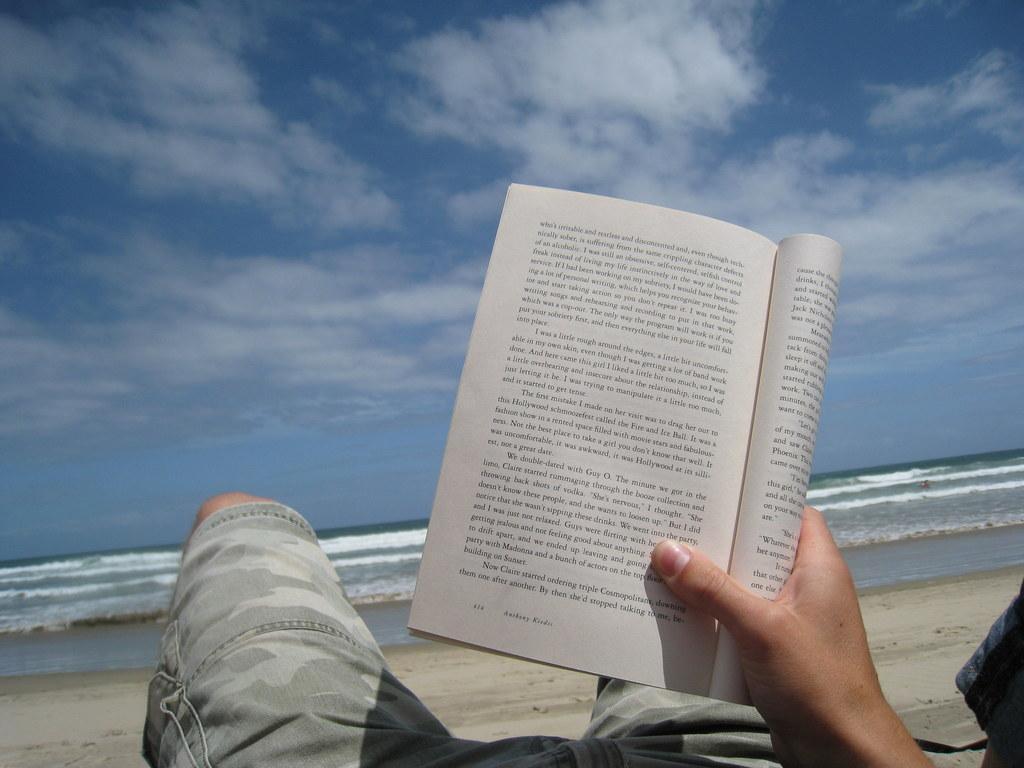Describe this image in one or two sentences. The image is taken at the beach. In the center of the image we can see a man lying and holding a book in his hand. In the background there is a sea and sky. 